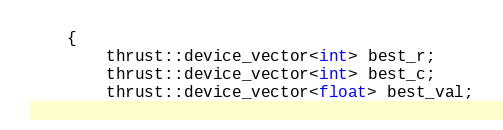<code> <loc_0><loc_0><loc_500><loc_500><_Cuda_>    {
        thrust::device_vector<int> best_r;
        thrust::device_vector<int> best_c;
        thrust::device_vector<float> best_val;</code> 